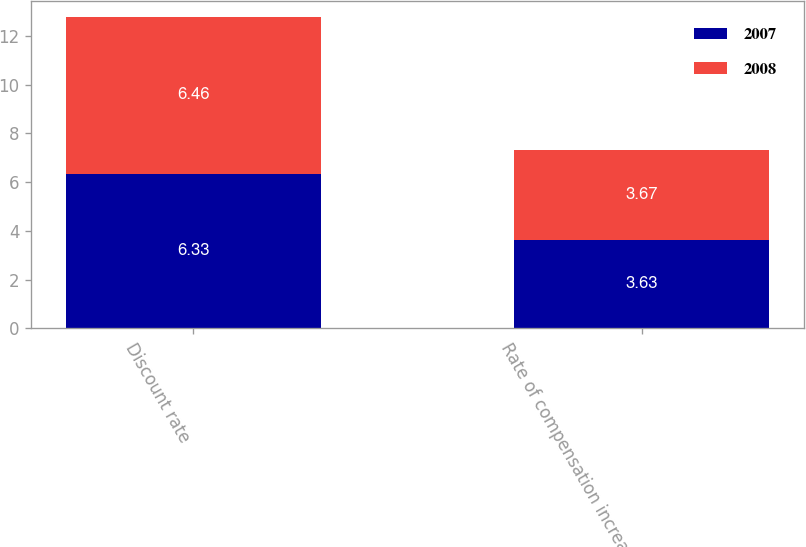<chart> <loc_0><loc_0><loc_500><loc_500><stacked_bar_chart><ecel><fcel>Discount rate<fcel>Rate of compensation increase<nl><fcel>2007<fcel>6.33<fcel>3.63<nl><fcel>2008<fcel>6.46<fcel>3.67<nl></chart> 